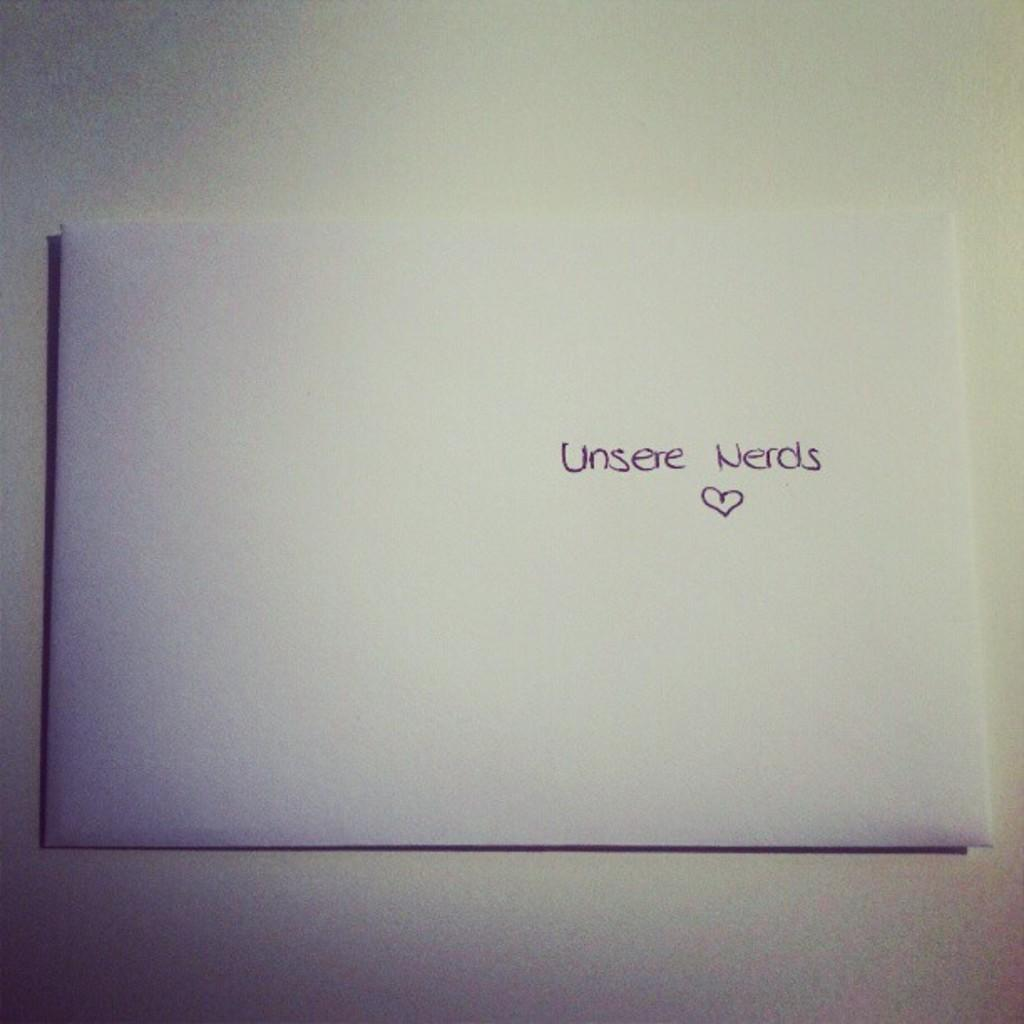<image>
Relay a brief, clear account of the picture shown. A plain white envelope as the words  Unsere Nerds written on it 